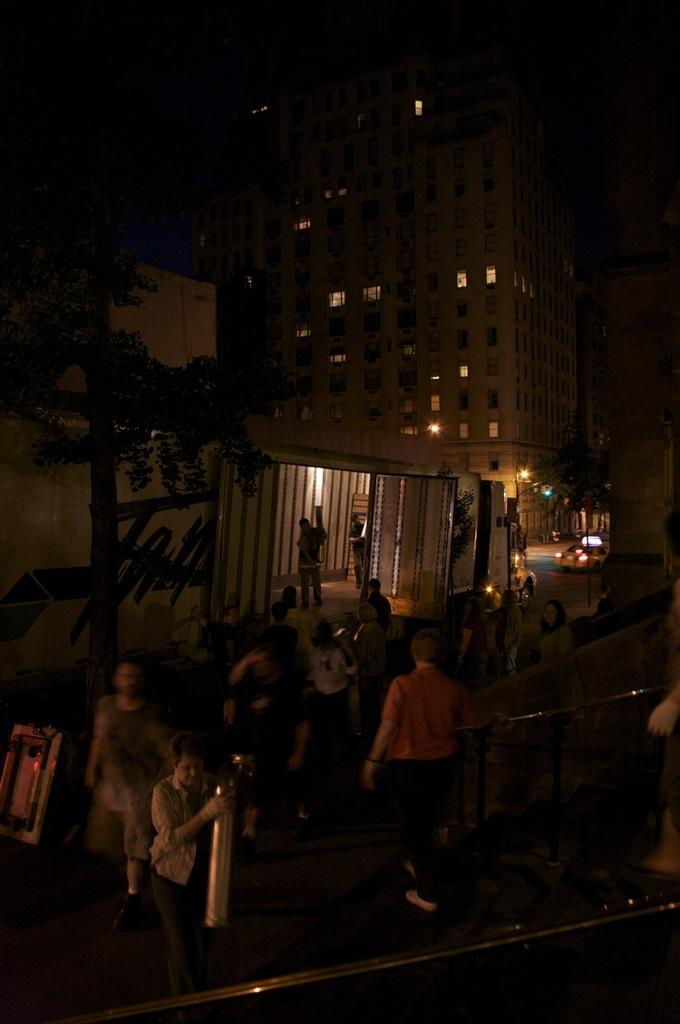What are the people in the image doing? The people in the image are standing and walking. What can be seen in the distance in the image? There are buildings and trees in the background of the image. What else is visible in the image? There are lights and vehicles visible in the image. What type of tail can be seen on the person walking in the image? There are no tails visible on any person in the image. Is the image set during the night? The image does not provide any information about the time of day, so it cannot be determined if it is set during the night. 